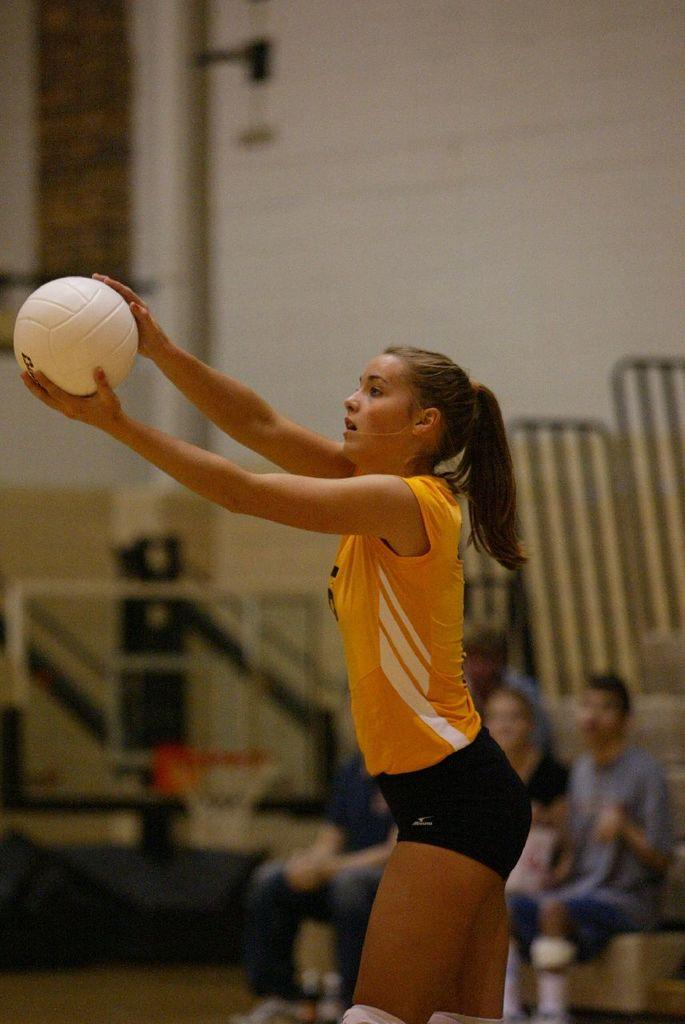Who is the main subject in the image? There is a woman in the image. What is the woman holding in her hand? The woman is holding a ball in her hand. What can be seen in the background of the image? There are persons sitting on chairs and a wall visible in the background of the image. What type of land can be seen in the image? There is no land visible in the image; it is an indoor setting with a woman holding a ball and persons sitting on chairs in the background. 